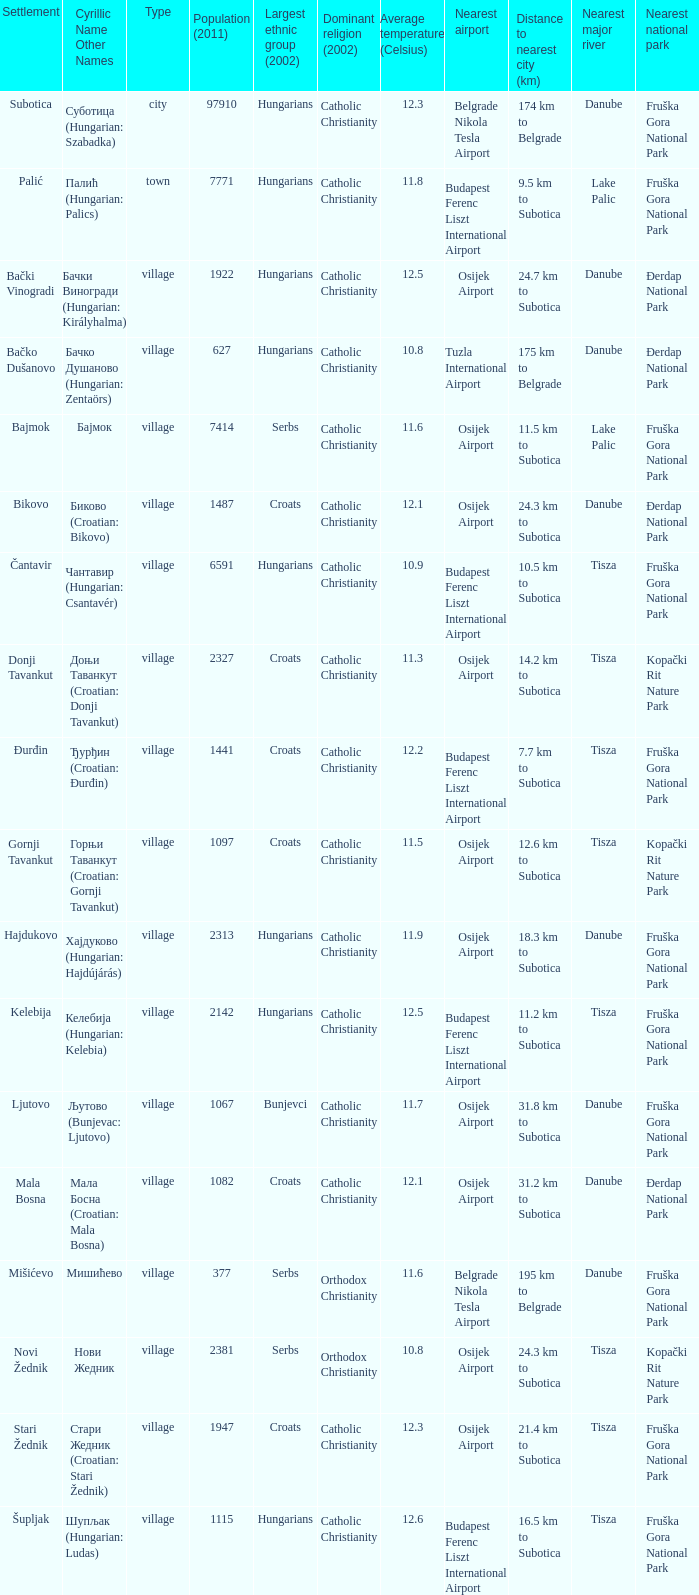What is the dominant religion in Gornji Tavankut? Catholic Christianity. 